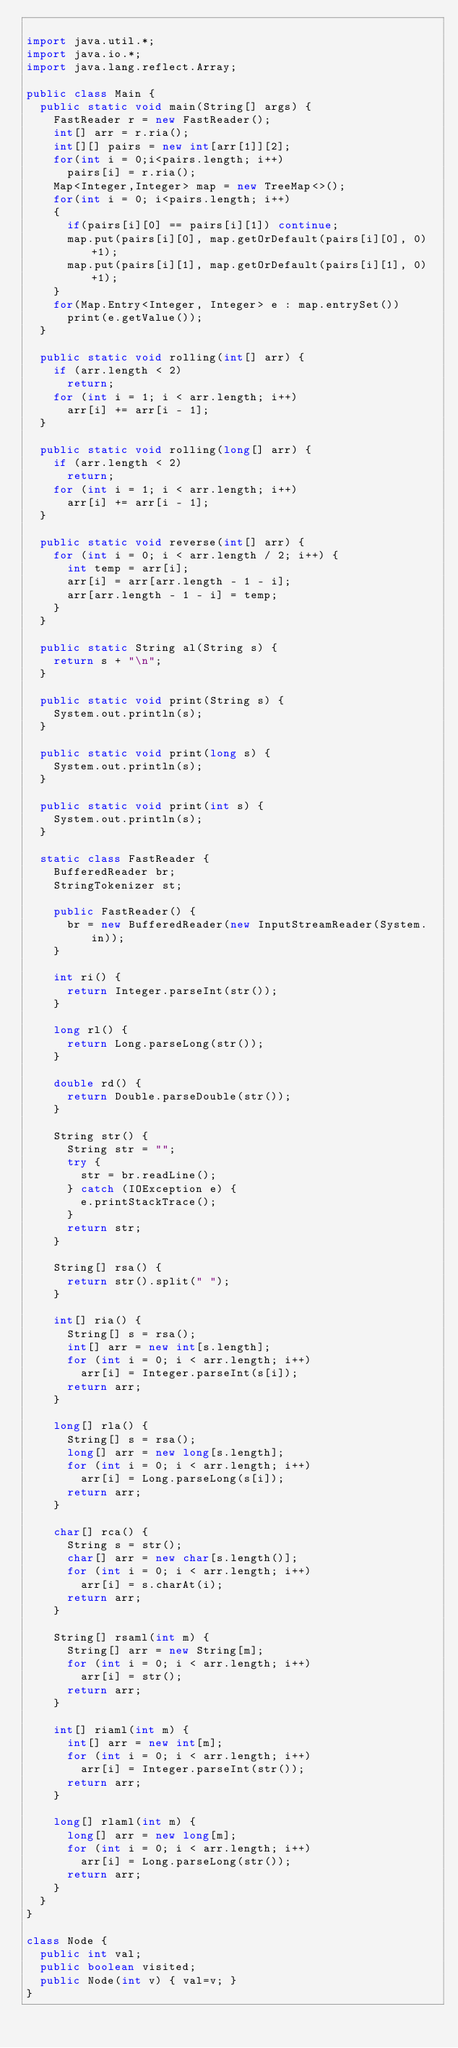Convert code to text. <code><loc_0><loc_0><loc_500><loc_500><_Java_>
import java.util.*;
import java.io.*;
import java.lang.reflect.Array;

public class Main {
	public static void main(String[] args) {
		FastReader r = new FastReader();		
		int[] arr = r.ria();
		int[][] pairs = new int[arr[1]][2];
		for(int i = 0;i<pairs.length; i++)
			pairs[i] = r.ria();
		Map<Integer,Integer> map = new TreeMap<>();
		for(int i = 0; i<pairs.length; i++)
		{
			if(pairs[i][0] == pairs[i][1]) continue;
			map.put(pairs[i][0], map.getOrDefault(pairs[i][0], 0)+1);
			map.put(pairs[i][1], map.getOrDefault(pairs[i][1], 0)+1);
		}
		for(Map.Entry<Integer, Integer> e : map.entrySet())
			print(e.getValue());
	}

	public static void rolling(int[] arr) {
		if (arr.length < 2)
			return;
		for (int i = 1; i < arr.length; i++)
			arr[i] += arr[i - 1];
	}
	
	public static void rolling(long[] arr) {
		if (arr.length < 2)
			return;
		for (int i = 1; i < arr.length; i++)
			arr[i] += arr[i - 1];
	}

	public static void reverse(int[] arr) {
		for (int i = 0; i < arr.length / 2; i++) {
			int temp = arr[i];
			arr[i] = arr[arr.length - 1 - i];
			arr[arr.length - 1 - i] = temp;
		}
	}
	
	public static String al(String s) {
		return s + "\n";
	}

	public static void print(String s) {
		System.out.println(s);
	}

	public static void print(long s) {
		System.out.println(s);
	}

	public static void print(int s) {
		System.out.println(s);
	}

	static class FastReader {
		BufferedReader br;
		StringTokenizer st;

		public FastReader() {
			br = new BufferedReader(new InputStreamReader(System.in));
		}

		int ri() {
			return Integer.parseInt(str());
		}

		long rl() {
			return Long.parseLong(str());
		}

		double rd() {
			return Double.parseDouble(str());
		}

		String str() {
			String str = "";
			try {
				str = br.readLine();
			} catch (IOException e) {
				e.printStackTrace();
			}
			return str;
		}

		String[] rsa() {
			return str().split(" ");
		}

		int[] ria() {
			String[] s = rsa();
			int[] arr = new int[s.length];
			for (int i = 0; i < arr.length; i++)
				arr[i] = Integer.parseInt(s[i]);
			return arr;
		}

		long[] rla() {
			String[] s = rsa();
			long[] arr = new long[s.length];
			for (int i = 0; i < arr.length; i++)
				arr[i] = Long.parseLong(s[i]);
			return arr;
		}

		char[] rca() {
			String s = str();
			char[] arr = new char[s.length()];
			for (int i = 0; i < arr.length; i++)
				arr[i] = s.charAt(i);
			return arr;
		}
		
		String[] rsaml(int m) {
			String[] arr = new String[m];
			for (int i = 0; i < arr.length; i++)
				arr[i] = str();
			return arr;
		}

		int[] riaml(int m) {
			int[] arr = new int[m];
			for (int i = 0; i < arr.length; i++)
				arr[i] = Integer.parseInt(str());
			return arr;
		}

		long[] rlaml(int m) {
			long[] arr = new long[m];
			for (int i = 0; i < arr.length; i++)
				arr[i] = Long.parseLong(str());
			return arr;
		}
	}
}

class Node {
	public int val;
	public boolean visited;
	public Node(int v) { val=v; }
}</code> 